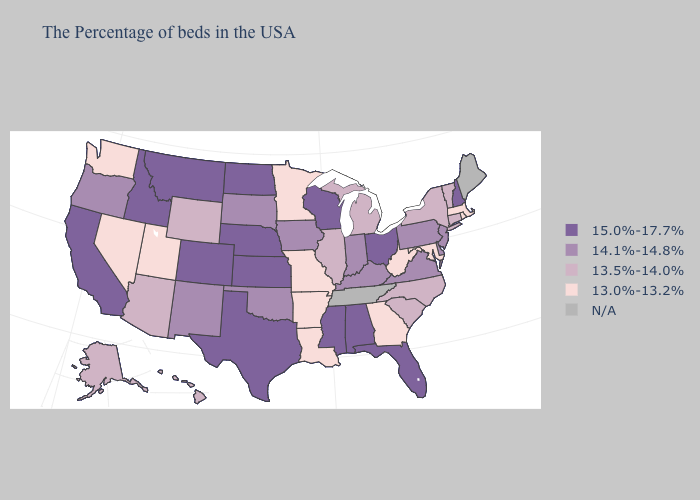Does Indiana have the highest value in the MidWest?
Concise answer only. No. Name the states that have a value in the range 14.1%-14.8%?
Keep it brief. New Jersey, Delaware, Pennsylvania, Virginia, Kentucky, Indiana, Iowa, Oklahoma, South Dakota, New Mexico, Oregon. Does New Jersey have the lowest value in the Northeast?
Keep it brief. No. Name the states that have a value in the range N/A?
Short answer required. Maine, Tennessee. Does Kansas have the highest value in the MidWest?
Concise answer only. Yes. Name the states that have a value in the range N/A?
Write a very short answer. Maine, Tennessee. Name the states that have a value in the range N/A?
Write a very short answer. Maine, Tennessee. Name the states that have a value in the range N/A?
Short answer required. Maine, Tennessee. Does Ohio have the highest value in the USA?
Quick response, please. Yes. Name the states that have a value in the range 13.5%-14.0%?
Answer briefly. Vermont, Connecticut, New York, North Carolina, South Carolina, Michigan, Illinois, Wyoming, Arizona, Alaska, Hawaii. Is the legend a continuous bar?
Keep it brief. No. What is the value of Washington?
Write a very short answer. 13.0%-13.2%. 